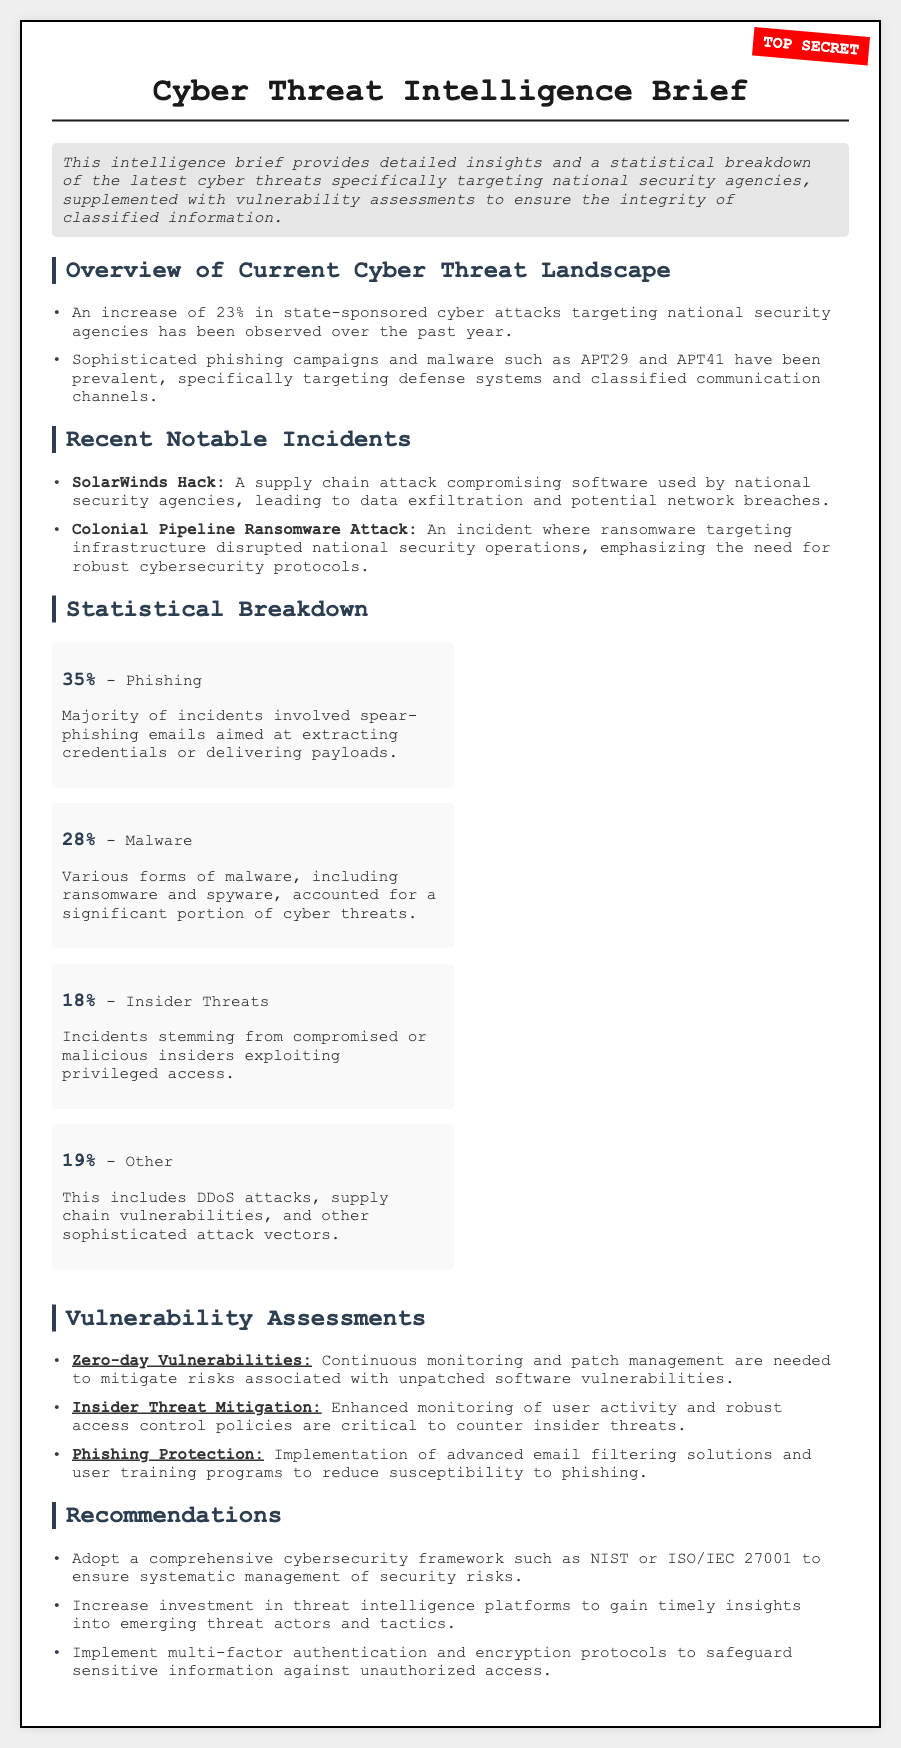What is the percentage increase in state-sponsored cyber attacks? The document states an increase of 23% in state-sponsored cyber attacks targeting national security agencies over the past year.
Answer: 23% What are the two main types of sophisticated attacks mentioned? The document specifically mentions phishing campaigns and malware such as APT29 and APT41 as prevalent attacks.
Answer: Phishing and malware What incident involved a supply chain attack? The document cites the SolarWinds Hack as a notable incident involving a supply chain attack.
Answer: SolarWinds Hack What percentage of incidents involved phishing? The document states that 35% of the incidents involved phishing as the major type.
Answer: 35% What is the percentage of incidents that involved insider threats? The document specifies that 18% of incidents stemmed from insider threats.
Answer: 18% What mitigation strategy addresses zero-day vulnerabilities? The document highlights that continuous monitoring and patch management are needed for zero-day vulnerabilities.
Answer: Continuous monitoring and patch management What cybersecurity framework is recommended in the document? The document suggests adopting a comprehensive cybersecurity framework such as NIST or ISO/IEC 27001.
Answer: NIST or ISO/IEC 27001 What type of attack accounts for 19% of the incidents? The document describes that "Other" attacks, which include DDoS and supply chain vulnerabilities, account for 19% of incidents.
Answer: Other What recommendation is provided for protecting against phishing? The document emphasizes the implementation of advanced email filtering solutions and user training programs to mitigate phishing risks.
Answer: Advanced email filtering solutions and user training programs 